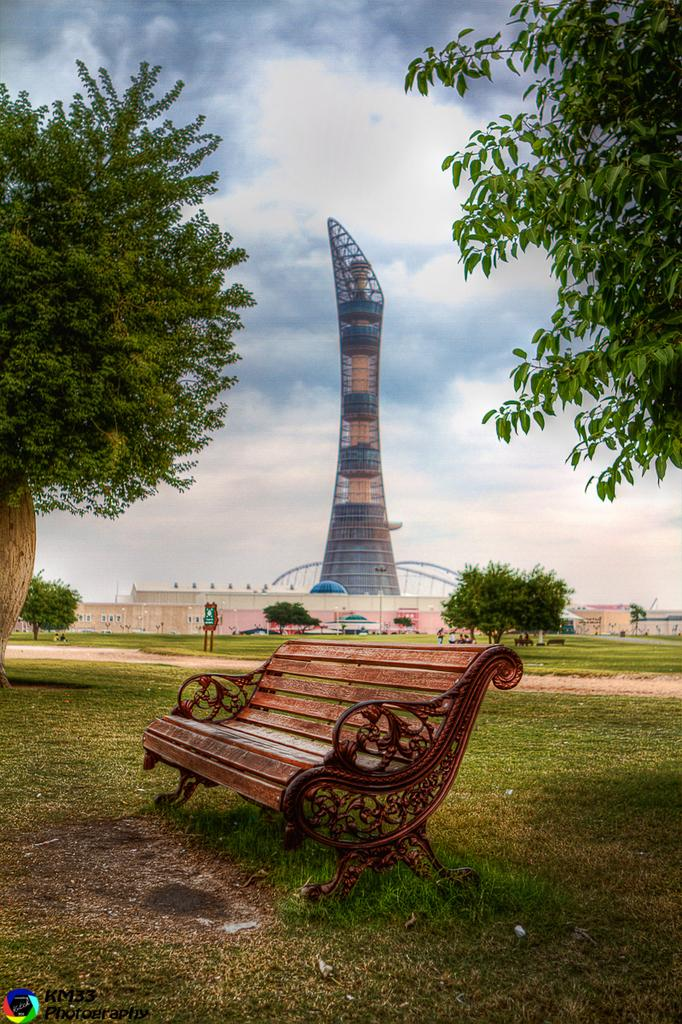What is located in the center of the image? There is a bench in the center of the image. What structure can be seen in the image? There is a tower in the image. What type of vegetation is present in the image? There are trees in the image. What type of buildings are on the right side of the image? There are sheds on the right side of the image. What is visible at the top of the image? The sky is visible in the image. Can you tell me how many calculators are on the bench in the image? There is no calculator present on the bench in the image. What type of dinner is being served in the tower in the image? There is no dinner being served in the image, as it features a bench, tower, trees, sheds, and the sky. 